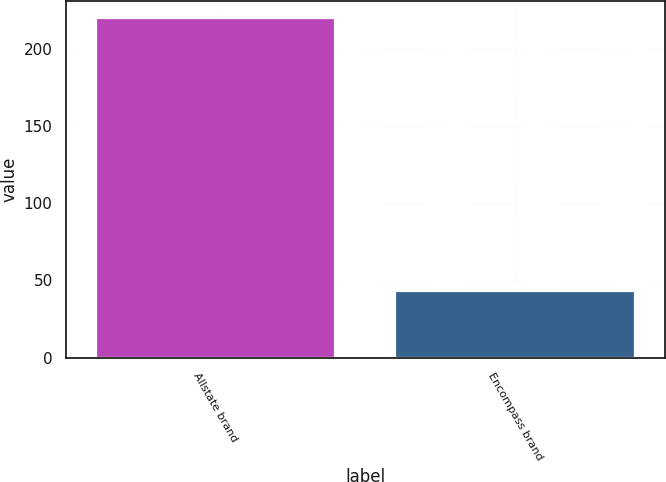Convert chart to OTSL. <chart><loc_0><loc_0><loc_500><loc_500><bar_chart><fcel>Allstate brand<fcel>Encompass brand<nl><fcel>220<fcel>43<nl></chart> 